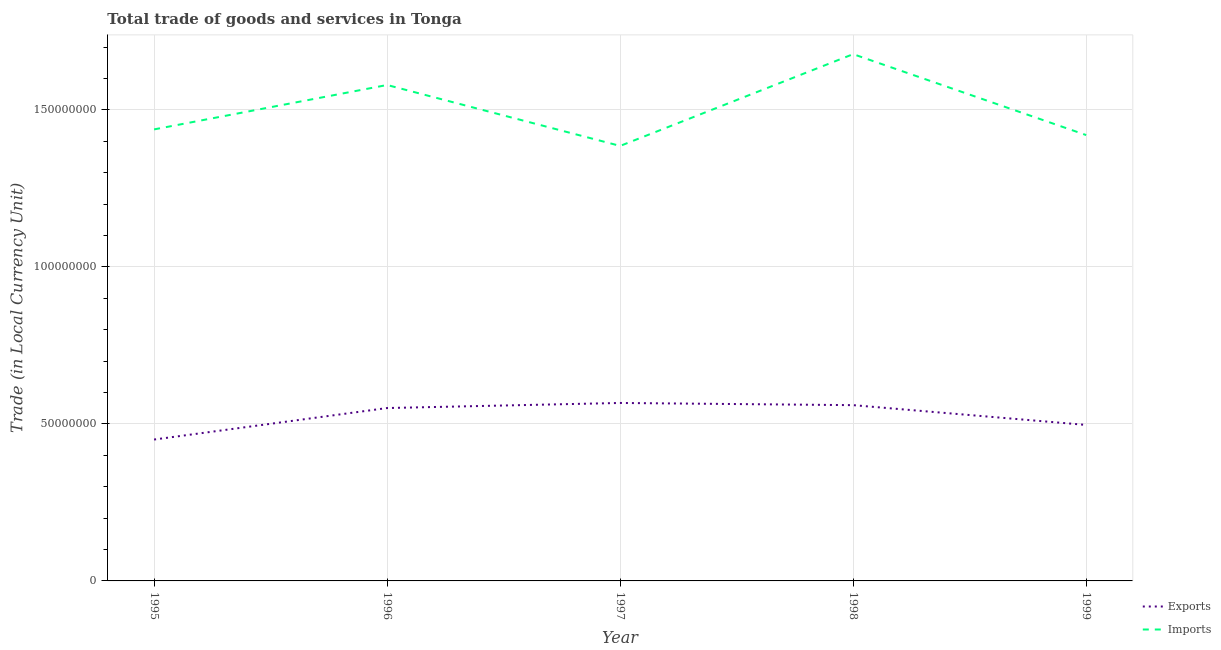Is the number of lines equal to the number of legend labels?
Your answer should be compact. Yes. What is the export of goods and services in 1996?
Your response must be concise. 5.50e+07. Across all years, what is the maximum export of goods and services?
Provide a short and direct response. 5.67e+07. Across all years, what is the minimum imports of goods and services?
Offer a very short reply. 1.39e+08. In which year was the imports of goods and services maximum?
Offer a terse response. 1998. What is the total export of goods and services in the graph?
Your response must be concise. 2.62e+08. What is the difference between the imports of goods and services in 1995 and that in 1996?
Your answer should be very brief. -1.41e+07. What is the difference between the imports of goods and services in 1998 and the export of goods and services in 1995?
Offer a terse response. 1.23e+08. What is the average imports of goods and services per year?
Your answer should be very brief. 1.50e+08. In the year 1998, what is the difference between the imports of goods and services and export of goods and services?
Offer a very short reply. 1.12e+08. What is the ratio of the imports of goods and services in 1996 to that in 1998?
Your answer should be very brief. 0.94. What is the difference between the highest and the second highest imports of goods and services?
Your answer should be compact. 9.82e+06. What is the difference between the highest and the lowest export of goods and services?
Provide a short and direct response. 1.16e+07. In how many years, is the export of goods and services greater than the average export of goods and services taken over all years?
Your answer should be compact. 3. Is the sum of the imports of goods and services in 1997 and 1998 greater than the maximum export of goods and services across all years?
Your answer should be very brief. Yes. Does the export of goods and services monotonically increase over the years?
Your response must be concise. No. Is the export of goods and services strictly greater than the imports of goods and services over the years?
Give a very brief answer. No. How many years are there in the graph?
Provide a short and direct response. 5. What is the difference between two consecutive major ticks on the Y-axis?
Provide a short and direct response. 5.00e+07. Does the graph contain any zero values?
Make the answer very short. No. Where does the legend appear in the graph?
Your response must be concise. Bottom right. How many legend labels are there?
Give a very brief answer. 2. What is the title of the graph?
Keep it short and to the point. Total trade of goods and services in Tonga. Does "Central government" appear as one of the legend labels in the graph?
Ensure brevity in your answer.  No. What is the label or title of the X-axis?
Give a very brief answer. Year. What is the label or title of the Y-axis?
Ensure brevity in your answer.  Trade (in Local Currency Unit). What is the Trade (in Local Currency Unit) in Exports in 1995?
Your response must be concise. 4.50e+07. What is the Trade (in Local Currency Unit) of Imports in 1995?
Ensure brevity in your answer.  1.44e+08. What is the Trade (in Local Currency Unit) of Exports in 1996?
Provide a short and direct response. 5.50e+07. What is the Trade (in Local Currency Unit) of Imports in 1996?
Ensure brevity in your answer.  1.58e+08. What is the Trade (in Local Currency Unit) in Exports in 1997?
Provide a succinct answer. 5.67e+07. What is the Trade (in Local Currency Unit) in Imports in 1997?
Ensure brevity in your answer.  1.39e+08. What is the Trade (in Local Currency Unit) in Exports in 1998?
Provide a succinct answer. 5.60e+07. What is the Trade (in Local Currency Unit) in Imports in 1998?
Your answer should be compact. 1.68e+08. What is the Trade (in Local Currency Unit) of Exports in 1999?
Make the answer very short. 4.97e+07. What is the Trade (in Local Currency Unit) in Imports in 1999?
Provide a succinct answer. 1.42e+08. Across all years, what is the maximum Trade (in Local Currency Unit) of Exports?
Offer a very short reply. 5.67e+07. Across all years, what is the maximum Trade (in Local Currency Unit) of Imports?
Provide a short and direct response. 1.68e+08. Across all years, what is the minimum Trade (in Local Currency Unit) in Exports?
Give a very brief answer. 4.50e+07. Across all years, what is the minimum Trade (in Local Currency Unit) in Imports?
Offer a terse response. 1.39e+08. What is the total Trade (in Local Currency Unit) in Exports in the graph?
Your answer should be very brief. 2.62e+08. What is the total Trade (in Local Currency Unit) in Imports in the graph?
Give a very brief answer. 7.50e+08. What is the difference between the Trade (in Local Currency Unit) of Exports in 1995 and that in 1996?
Provide a succinct answer. -1.00e+07. What is the difference between the Trade (in Local Currency Unit) of Imports in 1995 and that in 1996?
Your response must be concise. -1.41e+07. What is the difference between the Trade (in Local Currency Unit) in Exports in 1995 and that in 1997?
Your answer should be compact. -1.16e+07. What is the difference between the Trade (in Local Currency Unit) in Imports in 1995 and that in 1997?
Your answer should be compact. 5.26e+06. What is the difference between the Trade (in Local Currency Unit) in Exports in 1995 and that in 1998?
Keep it short and to the point. -1.09e+07. What is the difference between the Trade (in Local Currency Unit) of Imports in 1995 and that in 1998?
Your answer should be compact. -2.40e+07. What is the difference between the Trade (in Local Currency Unit) in Exports in 1995 and that in 1999?
Provide a succinct answer. -4.65e+06. What is the difference between the Trade (in Local Currency Unit) of Imports in 1995 and that in 1999?
Keep it short and to the point. 1.81e+06. What is the difference between the Trade (in Local Currency Unit) in Exports in 1996 and that in 1997?
Your answer should be compact. -1.62e+06. What is the difference between the Trade (in Local Currency Unit) in Imports in 1996 and that in 1997?
Provide a succinct answer. 1.94e+07. What is the difference between the Trade (in Local Currency Unit) of Exports in 1996 and that in 1998?
Ensure brevity in your answer.  -9.20e+05. What is the difference between the Trade (in Local Currency Unit) of Imports in 1996 and that in 1998?
Your answer should be compact. -9.82e+06. What is the difference between the Trade (in Local Currency Unit) of Exports in 1996 and that in 1999?
Provide a short and direct response. 5.38e+06. What is the difference between the Trade (in Local Currency Unit) of Imports in 1996 and that in 1999?
Your answer should be compact. 1.59e+07. What is the difference between the Trade (in Local Currency Unit) of Exports in 1997 and that in 1998?
Ensure brevity in your answer.  6.97e+05. What is the difference between the Trade (in Local Currency Unit) of Imports in 1997 and that in 1998?
Ensure brevity in your answer.  -2.92e+07. What is the difference between the Trade (in Local Currency Unit) of Exports in 1997 and that in 1999?
Offer a very short reply. 7.00e+06. What is the difference between the Trade (in Local Currency Unit) of Imports in 1997 and that in 1999?
Give a very brief answer. -3.45e+06. What is the difference between the Trade (in Local Currency Unit) in Exports in 1998 and that in 1999?
Your answer should be very brief. 6.30e+06. What is the difference between the Trade (in Local Currency Unit) of Imports in 1998 and that in 1999?
Offer a very short reply. 2.58e+07. What is the difference between the Trade (in Local Currency Unit) in Exports in 1995 and the Trade (in Local Currency Unit) in Imports in 1996?
Offer a very short reply. -1.13e+08. What is the difference between the Trade (in Local Currency Unit) in Exports in 1995 and the Trade (in Local Currency Unit) in Imports in 1997?
Your answer should be very brief. -9.35e+07. What is the difference between the Trade (in Local Currency Unit) in Exports in 1995 and the Trade (in Local Currency Unit) in Imports in 1998?
Offer a very short reply. -1.23e+08. What is the difference between the Trade (in Local Currency Unit) in Exports in 1995 and the Trade (in Local Currency Unit) in Imports in 1999?
Give a very brief answer. -9.69e+07. What is the difference between the Trade (in Local Currency Unit) in Exports in 1996 and the Trade (in Local Currency Unit) in Imports in 1997?
Your response must be concise. -8.35e+07. What is the difference between the Trade (in Local Currency Unit) of Exports in 1996 and the Trade (in Local Currency Unit) of Imports in 1998?
Your answer should be compact. -1.13e+08. What is the difference between the Trade (in Local Currency Unit) of Exports in 1996 and the Trade (in Local Currency Unit) of Imports in 1999?
Provide a succinct answer. -8.69e+07. What is the difference between the Trade (in Local Currency Unit) of Exports in 1997 and the Trade (in Local Currency Unit) of Imports in 1998?
Offer a very short reply. -1.11e+08. What is the difference between the Trade (in Local Currency Unit) of Exports in 1997 and the Trade (in Local Currency Unit) of Imports in 1999?
Your answer should be compact. -8.53e+07. What is the difference between the Trade (in Local Currency Unit) of Exports in 1998 and the Trade (in Local Currency Unit) of Imports in 1999?
Your response must be concise. -8.60e+07. What is the average Trade (in Local Currency Unit) in Exports per year?
Your response must be concise. 5.25e+07. What is the average Trade (in Local Currency Unit) of Imports per year?
Your answer should be very brief. 1.50e+08. In the year 1995, what is the difference between the Trade (in Local Currency Unit) of Exports and Trade (in Local Currency Unit) of Imports?
Make the answer very short. -9.88e+07. In the year 1996, what is the difference between the Trade (in Local Currency Unit) in Exports and Trade (in Local Currency Unit) in Imports?
Provide a succinct answer. -1.03e+08. In the year 1997, what is the difference between the Trade (in Local Currency Unit) in Exports and Trade (in Local Currency Unit) in Imports?
Your response must be concise. -8.18e+07. In the year 1998, what is the difference between the Trade (in Local Currency Unit) in Exports and Trade (in Local Currency Unit) in Imports?
Provide a short and direct response. -1.12e+08. In the year 1999, what is the difference between the Trade (in Local Currency Unit) of Exports and Trade (in Local Currency Unit) of Imports?
Ensure brevity in your answer.  -9.23e+07. What is the ratio of the Trade (in Local Currency Unit) in Exports in 1995 to that in 1996?
Keep it short and to the point. 0.82. What is the ratio of the Trade (in Local Currency Unit) in Imports in 1995 to that in 1996?
Your answer should be compact. 0.91. What is the ratio of the Trade (in Local Currency Unit) of Exports in 1995 to that in 1997?
Make the answer very short. 0.79. What is the ratio of the Trade (in Local Currency Unit) in Imports in 1995 to that in 1997?
Make the answer very short. 1.04. What is the ratio of the Trade (in Local Currency Unit) of Exports in 1995 to that in 1998?
Provide a succinct answer. 0.8. What is the ratio of the Trade (in Local Currency Unit) of Imports in 1995 to that in 1998?
Your answer should be compact. 0.86. What is the ratio of the Trade (in Local Currency Unit) in Exports in 1995 to that in 1999?
Offer a terse response. 0.91. What is the ratio of the Trade (in Local Currency Unit) in Imports in 1995 to that in 1999?
Give a very brief answer. 1.01. What is the ratio of the Trade (in Local Currency Unit) of Exports in 1996 to that in 1997?
Your answer should be compact. 0.97. What is the ratio of the Trade (in Local Currency Unit) in Imports in 1996 to that in 1997?
Offer a terse response. 1.14. What is the ratio of the Trade (in Local Currency Unit) in Exports in 1996 to that in 1998?
Ensure brevity in your answer.  0.98. What is the ratio of the Trade (in Local Currency Unit) of Imports in 1996 to that in 1998?
Give a very brief answer. 0.94. What is the ratio of the Trade (in Local Currency Unit) of Exports in 1996 to that in 1999?
Offer a very short reply. 1.11. What is the ratio of the Trade (in Local Currency Unit) of Imports in 1996 to that in 1999?
Your answer should be very brief. 1.11. What is the ratio of the Trade (in Local Currency Unit) of Exports in 1997 to that in 1998?
Provide a short and direct response. 1.01. What is the ratio of the Trade (in Local Currency Unit) of Imports in 1997 to that in 1998?
Offer a very short reply. 0.83. What is the ratio of the Trade (in Local Currency Unit) of Exports in 1997 to that in 1999?
Ensure brevity in your answer.  1.14. What is the ratio of the Trade (in Local Currency Unit) of Imports in 1997 to that in 1999?
Offer a terse response. 0.98. What is the ratio of the Trade (in Local Currency Unit) of Exports in 1998 to that in 1999?
Provide a short and direct response. 1.13. What is the ratio of the Trade (in Local Currency Unit) in Imports in 1998 to that in 1999?
Make the answer very short. 1.18. What is the difference between the highest and the second highest Trade (in Local Currency Unit) in Exports?
Your answer should be compact. 6.97e+05. What is the difference between the highest and the second highest Trade (in Local Currency Unit) of Imports?
Your answer should be very brief. 9.82e+06. What is the difference between the highest and the lowest Trade (in Local Currency Unit) in Exports?
Offer a very short reply. 1.16e+07. What is the difference between the highest and the lowest Trade (in Local Currency Unit) of Imports?
Ensure brevity in your answer.  2.92e+07. 